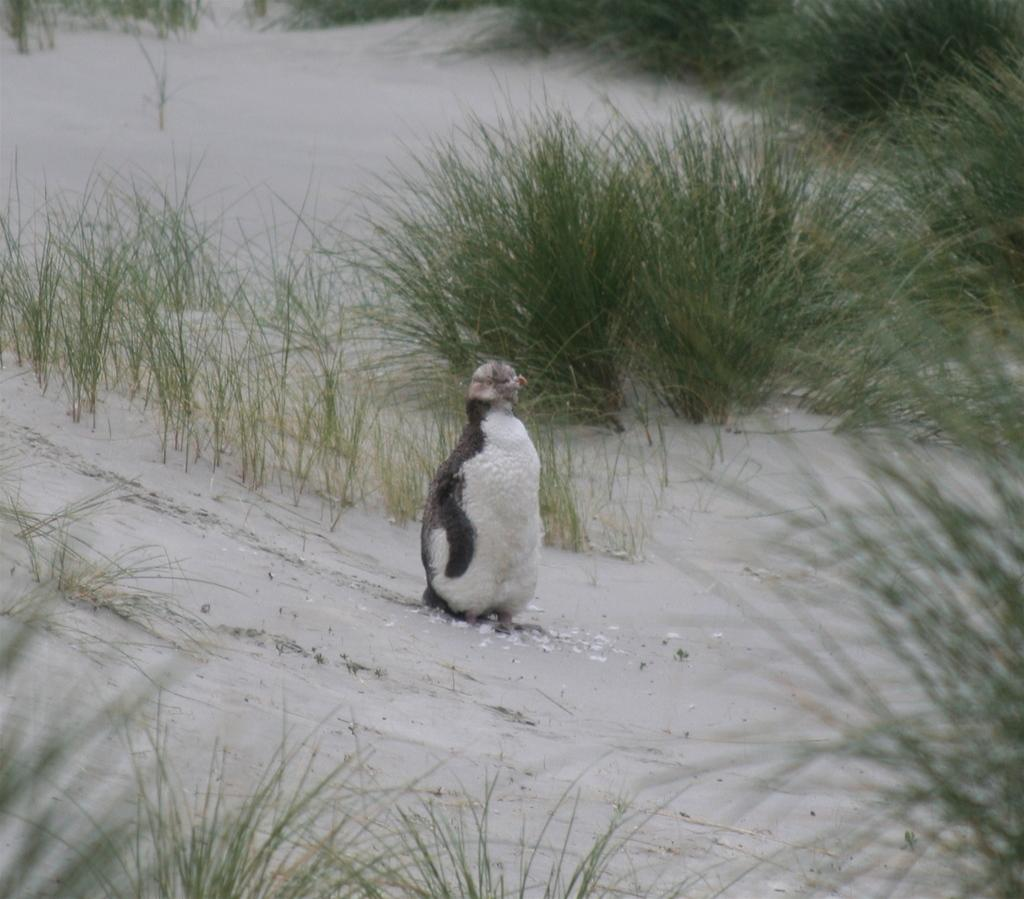What type of animal is in the image? There is a penguin in the image. What type of vegetation is present in the image? There is grass in the image. What type of weather or environment is depicted in the image? There is snow in the image. Reasoning: Let' Let's think step by step in order to produce the conversation. We start by identifying the main subject of the image, which is the penguin. Then, we describe the environment or setting by mentioning the presence of grass and snow. Each question is designed to elicit a specific detail about the image that is known from the provided facts. Absurd Question/Answer: What brand of toothpaste is the penguin using in the image? There is no toothpaste present in the image, and the penguin is not using any toothpaste. How many beans are visible in the image? There are no beans present in the image. 